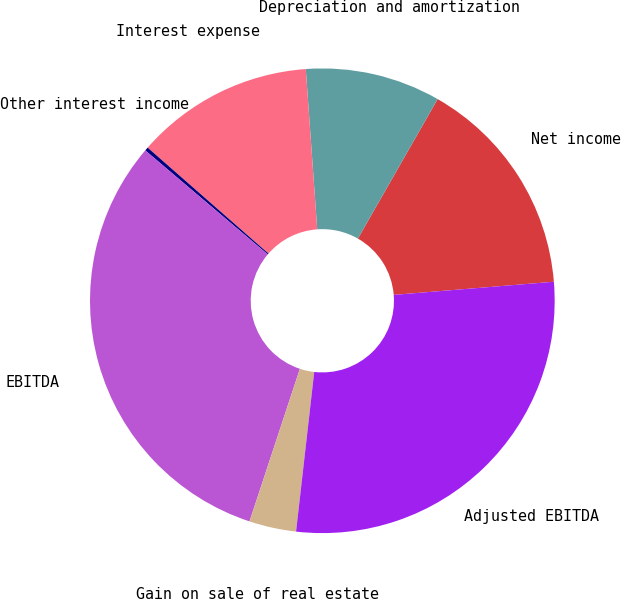Convert chart. <chart><loc_0><loc_0><loc_500><loc_500><pie_chart><fcel>Net income<fcel>Depreciation and amortization<fcel>Interest expense<fcel>Other interest income<fcel>EBITDA<fcel>Gain on sale of real estate<fcel>Adjusted EBITDA<nl><fcel>15.43%<fcel>9.4%<fcel>12.41%<fcel>0.25%<fcel>31.13%<fcel>3.27%<fcel>28.11%<nl></chart> 